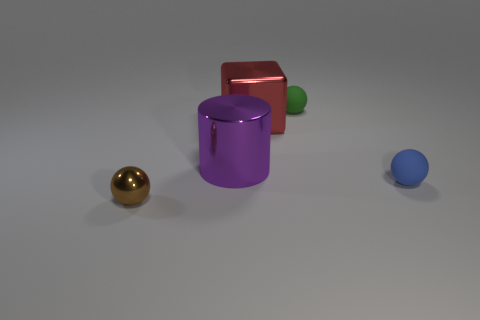Subtract all small metal balls. How many balls are left? 2 Add 3 metallic cylinders. How many objects exist? 8 Subtract all blue spheres. How many spheres are left? 2 Subtract all cylinders. How many objects are left? 4 Add 4 small metal things. How many small metal things are left? 5 Add 4 tiny red metal cylinders. How many tiny red metal cylinders exist? 4 Subtract 1 red cubes. How many objects are left? 4 Subtract 1 cylinders. How many cylinders are left? 0 Subtract all green cubes. Subtract all yellow cylinders. How many cubes are left? 1 Subtract all big purple things. Subtract all small spheres. How many objects are left? 1 